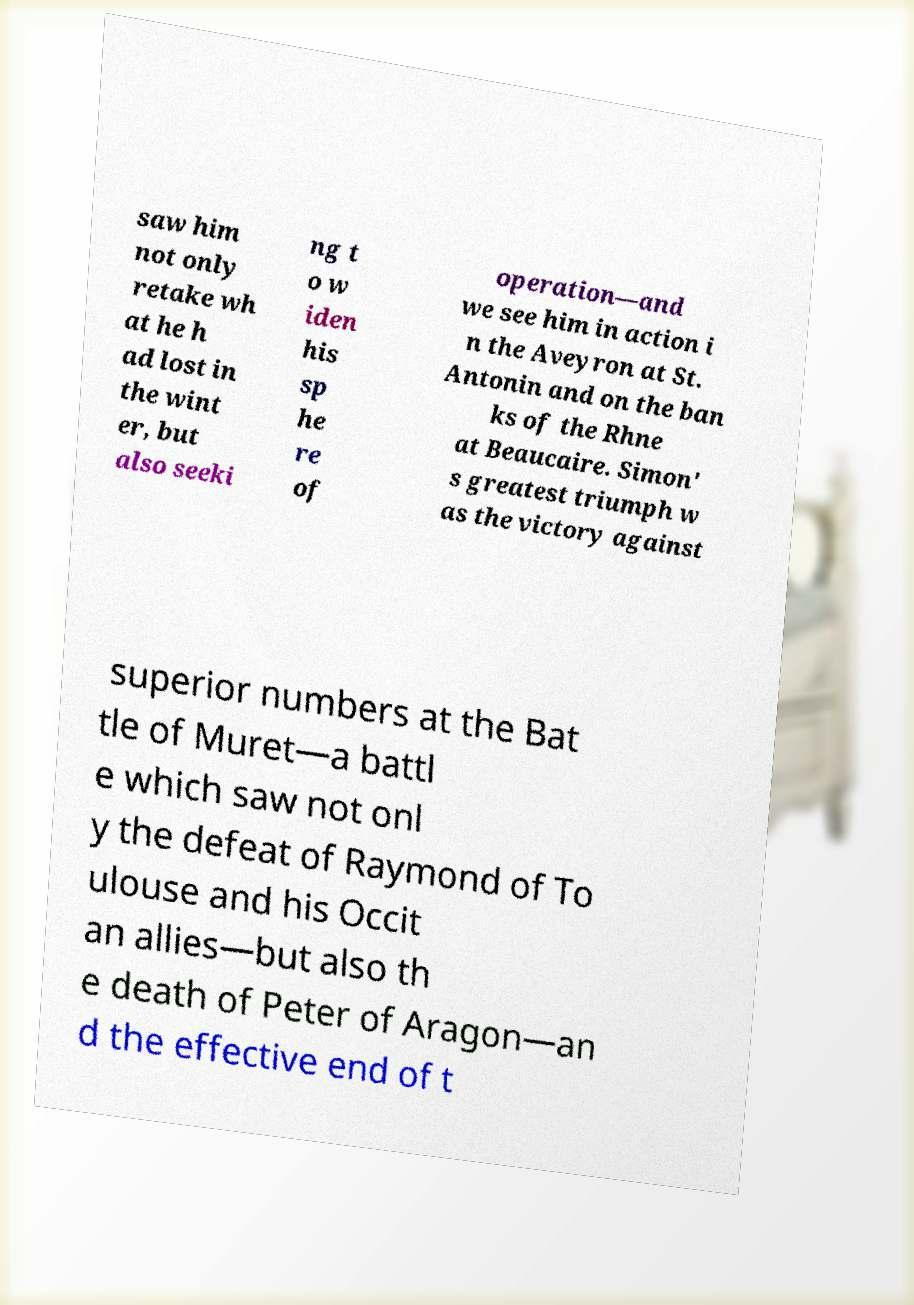Please identify and transcribe the text found in this image. saw him not only retake wh at he h ad lost in the wint er, but also seeki ng t o w iden his sp he re of operation—and we see him in action i n the Aveyron at St. Antonin and on the ban ks of the Rhne at Beaucaire. Simon' s greatest triumph w as the victory against superior numbers at the Bat tle of Muret—a battl e which saw not onl y the defeat of Raymond of To ulouse and his Occit an allies—but also th e death of Peter of Aragon—an d the effective end of t 